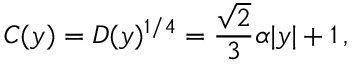Convert formula to latex. <formula><loc_0><loc_0><loc_500><loc_500>C ( y ) = D ( y ) ^ { 1 / 4 } = \frac { \sqrt { 2 } } { 3 } \alpha | y | + 1 \, ,</formula> 